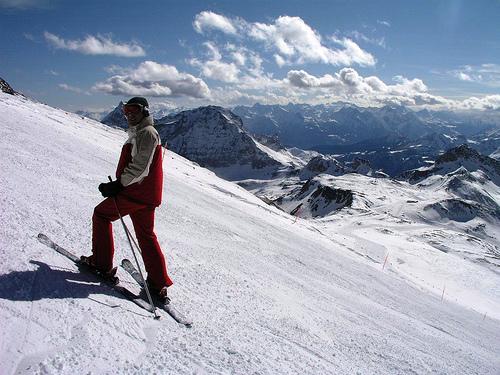What is covering the ground?
Give a very brief answer. Snow. What is this person climbing?
Answer briefly. Mountain. Are clouds in the sky?
Short answer required. Yes. 